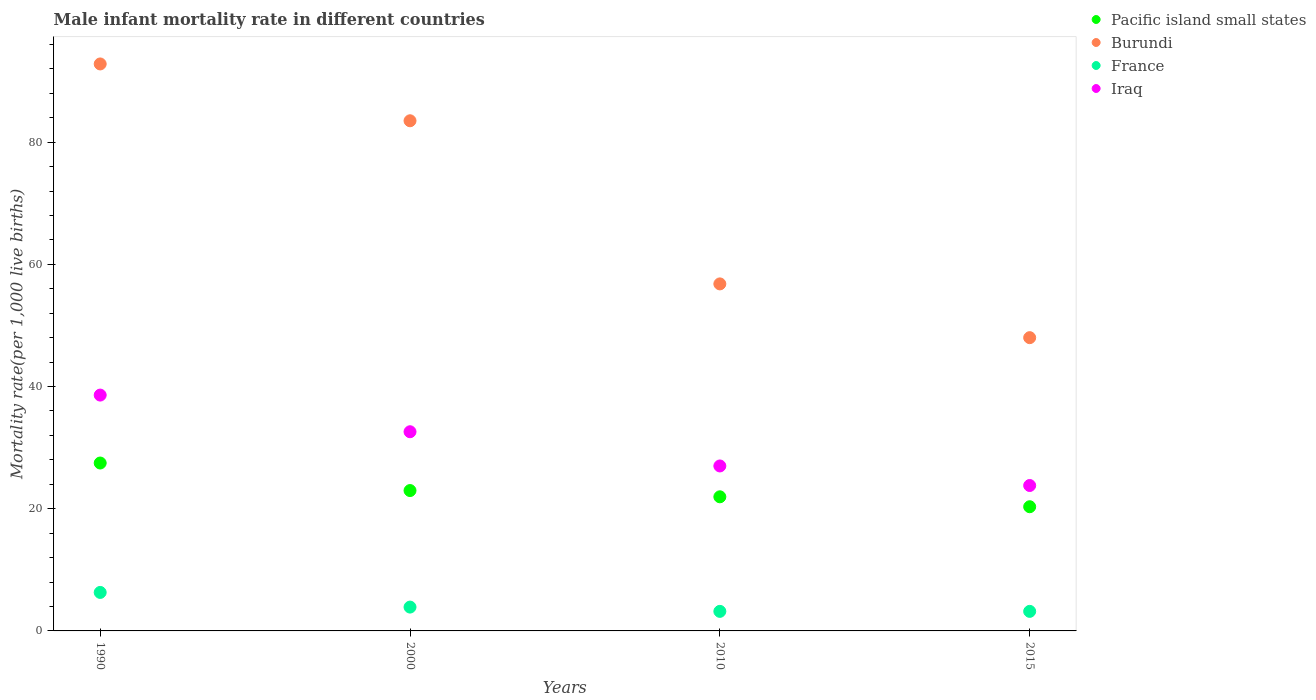How many different coloured dotlines are there?
Make the answer very short. 4. Is the number of dotlines equal to the number of legend labels?
Provide a succinct answer. Yes. What is the male infant mortality rate in Iraq in 2010?
Make the answer very short. 27. Across all years, what is the maximum male infant mortality rate in Pacific island small states?
Provide a short and direct response. 27.48. Across all years, what is the minimum male infant mortality rate in Pacific island small states?
Provide a succinct answer. 20.33. In which year was the male infant mortality rate in Iraq minimum?
Provide a short and direct response. 2015. What is the total male infant mortality rate in Iraq in the graph?
Provide a succinct answer. 122. What is the difference between the male infant mortality rate in France in 2000 and the male infant mortality rate in Burundi in 2010?
Make the answer very short. -52.9. What is the average male infant mortality rate in Pacific island small states per year?
Give a very brief answer. 23.18. In the year 2010, what is the difference between the male infant mortality rate in Pacific island small states and male infant mortality rate in Iraq?
Keep it short and to the point. -5.05. In how many years, is the male infant mortality rate in France greater than 64?
Give a very brief answer. 0. What is the ratio of the male infant mortality rate in Pacific island small states in 1990 to that in 2010?
Provide a short and direct response. 1.25. Is the male infant mortality rate in Iraq in 2000 less than that in 2010?
Make the answer very short. No. What is the difference between the highest and the lowest male infant mortality rate in France?
Keep it short and to the point. 3.1. In how many years, is the male infant mortality rate in Burundi greater than the average male infant mortality rate in Burundi taken over all years?
Keep it short and to the point. 2. Is it the case that in every year, the sum of the male infant mortality rate in Burundi and male infant mortality rate in Iraq  is greater than the sum of male infant mortality rate in France and male infant mortality rate in Pacific island small states?
Your answer should be very brief. Yes. Is it the case that in every year, the sum of the male infant mortality rate in Burundi and male infant mortality rate in Iraq  is greater than the male infant mortality rate in Pacific island small states?
Offer a terse response. Yes. Is the male infant mortality rate in Pacific island small states strictly greater than the male infant mortality rate in Iraq over the years?
Make the answer very short. No. Is the male infant mortality rate in France strictly less than the male infant mortality rate in Iraq over the years?
Your answer should be very brief. Yes. What is the difference between two consecutive major ticks on the Y-axis?
Make the answer very short. 20. Are the values on the major ticks of Y-axis written in scientific E-notation?
Provide a succinct answer. No. How many legend labels are there?
Your answer should be very brief. 4. How are the legend labels stacked?
Your response must be concise. Vertical. What is the title of the graph?
Your answer should be compact. Male infant mortality rate in different countries. What is the label or title of the Y-axis?
Ensure brevity in your answer.  Mortality rate(per 1,0 live births). What is the Mortality rate(per 1,000 live births) in Pacific island small states in 1990?
Offer a terse response. 27.48. What is the Mortality rate(per 1,000 live births) of Burundi in 1990?
Provide a short and direct response. 92.8. What is the Mortality rate(per 1,000 live births) of France in 1990?
Offer a terse response. 6.3. What is the Mortality rate(per 1,000 live births) in Iraq in 1990?
Offer a terse response. 38.6. What is the Mortality rate(per 1,000 live births) of Pacific island small states in 2000?
Your answer should be compact. 22.97. What is the Mortality rate(per 1,000 live births) of Burundi in 2000?
Provide a succinct answer. 83.5. What is the Mortality rate(per 1,000 live births) of Iraq in 2000?
Your answer should be compact. 32.6. What is the Mortality rate(per 1,000 live births) of Pacific island small states in 2010?
Offer a terse response. 21.95. What is the Mortality rate(per 1,000 live births) of Burundi in 2010?
Your response must be concise. 56.8. What is the Mortality rate(per 1,000 live births) in France in 2010?
Your answer should be very brief. 3.2. What is the Mortality rate(per 1,000 live births) of Pacific island small states in 2015?
Your response must be concise. 20.33. What is the Mortality rate(per 1,000 live births) of Iraq in 2015?
Provide a succinct answer. 23.8. Across all years, what is the maximum Mortality rate(per 1,000 live births) in Pacific island small states?
Ensure brevity in your answer.  27.48. Across all years, what is the maximum Mortality rate(per 1,000 live births) in Burundi?
Make the answer very short. 92.8. Across all years, what is the maximum Mortality rate(per 1,000 live births) in Iraq?
Ensure brevity in your answer.  38.6. Across all years, what is the minimum Mortality rate(per 1,000 live births) of Pacific island small states?
Ensure brevity in your answer.  20.33. Across all years, what is the minimum Mortality rate(per 1,000 live births) of Iraq?
Provide a succinct answer. 23.8. What is the total Mortality rate(per 1,000 live births) in Pacific island small states in the graph?
Make the answer very short. 92.73. What is the total Mortality rate(per 1,000 live births) in Burundi in the graph?
Offer a very short reply. 281.1. What is the total Mortality rate(per 1,000 live births) of Iraq in the graph?
Offer a terse response. 122. What is the difference between the Mortality rate(per 1,000 live births) of Pacific island small states in 1990 and that in 2000?
Offer a terse response. 4.51. What is the difference between the Mortality rate(per 1,000 live births) in France in 1990 and that in 2000?
Keep it short and to the point. 2.4. What is the difference between the Mortality rate(per 1,000 live births) of Pacific island small states in 1990 and that in 2010?
Offer a terse response. 5.53. What is the difference between the Mortality rate(per 1,000 live births) of France in 1990 and that in 2010?
Provide a short and direct response. 3.1. What is the difference between the Mortality rate(per 1,000 live births) in Pacific island small states in 1990 and that in 2015?
Offer a terse response. 7.16. What is the difference between the Mortality rate(per 1,000 live births) of Burundi in 1990 and that in 2015?
Ensure brevity in your answer.  44.8. What is the difference between the Mortality rate(per 1,000 live births) of France in 1990 and that in 2015?
Keep it short and to the point. 3.1. What is the difference between the Mortality rate(per 1,000 live births) in Iraq in 1990 and that in 2015?
Ensure brevity in your answer.  14.8. What is the difference between the Mortality rate(per 1,000 live births) of Pacific island small states in 2000 and that in 2010?
Ensure brevity in your answer.  1.02. What is the difference between the Mortality rate(per 1,000 live births) in Burundi in 2000 and that in 2010?
Keep it short and to the point. 26.7. What is the difference between the Mortality rate(per 1,000 live births) in Pacific island small states in 2000 and that in 2015?
Provide a short and direct response. 2.65. What is the difference between the Mortality rate(per 1,000 live births) in Burundi in 2000 and that in 2015?
Provide a short and direct response. 35.5. What is the difference between the Mortality rate(per 1,000 live births) of Pacific island small states in 2010 and that in 2015?
Offer a terse response. 1.62. What is the difference between the Mortality rate(per 1,000 live births) in Burundi in 2010 and that in 2015?
Your response must be concise. 8.8. What is the difference between the Mortality rate(per 1,000 live births) of Iraq in 2010 and that in 2015?
Make the answer very short. 3.2. What is the difference between the Mortality rate(per 1,000 live births) of Pacific island small states in 1990 and the Mortality rate(per 1,000 live births) of Burundi in 2000?
Ensure brevity in your answer.  -56.02. What is the difference between the Mortality rate(per 1,000 live births) of Pacific island small states in 1990 and the Mortality rate(per 1,000 live births) of France in 2000?
Make the answer very short. 23.58. What is the difference between the Mortality rate(per 1,000 live births) in Pacific island small states in 1990 and the Mortality rate(per 1,000 live births) in Iraq in 2000?
Your answer should be very brief. -5.12. What is the difference between the Mortality rate(per 1,000 live births) in Burundi in 1990 and the Mortality rate(per 1,000 live births) in France in 2000?
Provide a short and direct response. 88.9. What is the difference between the Mortality rate(per 1,000 live births) of Burundi in 1990 and the Mortality rate(per 1,000 live births) of Iraq in 2000?
Give a very brief answer. 60.2. What is the difference between the Mortality rate(per 1,000 live births) of France in 1990 and the Mortality rate(per 1,000 live births) of Iraq in 2000?
Ensure brevity in your answer.  -26.3. What is the difference between the Mortality rate(per 1,000 live births) of Pacific island small states in 1990 and the Mortality rate(per 1,000 live births) of Burundi in 2010?
Your answer should be compact. -29.32. What is the difference between the Mortality rate(per 1,000 live births) in Pacific island small states in 1990 and the Mortality rate(per 1,000 live births) in France in 2010?
Ensure brevity in your answer.  24.28. What is the difference between the Mortality rate(per 1,000 live births) of Pacific island small states in 1990 and the Mortality rate(per 1,000 live births) of Iraq in 2010?
Your answer should be compact. 0.48. What is the difference between the Mortality rate(per 1,000 live births) of Burundi in 1990 and the Mortality rate(per 1,000 live births) of France in 2010?
Keep it short and to the point. 89.6. What is the difference between the Mortality rate(per 1,000 live births) of Burundi in 1990 and the Mortality rate(per 1,000 live births) of Iraq in 2010?
Provide a short and direct response. 65.8. What is the difference between the Mortality rate(per 1,000 live births) of France in 1990 and the Mortality rate(per 1,000 live births) of Iraq in 2010?
Ensure brevity in your answer.  -20.7. What is the difference between the Mortality rate(per 1,000 live births) in Pacific island small states in 1990 and the Mortality rate(per 1,000 live births) in Burundi in 2015?
Your answer should be very brief. -20.52. What is the difference between the Mortality rate(per 1,000 live births) in Pacific island small states in 1990 and the Mortality rate(per 1,000 live births) in France in 2015?
Provide a succinct answer. 24.28. What is the difference between the Mortality rate(per 1,000 live births) of Pacific island small states in 1990 and the Mortality rate(per 1,000 live births) of Iraq in 2015?
Your response must be concise. 3.68. What is the difference between the Mortality rate(per 1,000 live births) in Burundi in 1990 and the Mortality rate(per 1,000 live births) in France in 2015?
Offer a very short reply. 89.6. What is the difference between the Mortality rate(per 1,000 live births) in France in 1990 and the Mortality rate(per 1,000 live births) in Iraq in 2015?
Offer a terse response. -17.5. What is the difference between the Mortality rate(per 1,000 live births) of Pacific island small states in 2000 and the Mortality rate(per 1,000 live births) of Burundi in 2010?
Make the answer very short. -33.83. What is the difference between the Mortality rate(per 1,000 live births) in Pacific island small states in 2000 and the Mortality rate(per 1,000 live births) in France in 2010?
Make the answer very short. 19.77. What is the difference between the Mortality rate(per 1,000 live births) in Pacific island small states in 2000 and the Mortality rate(per 1,000 live births) in Iraq in 2010?
Make the answer very short. -4.03. What is the difference between the Mortality rate(per 1,000 live births) of Burundi in 2000 and the Mortality rate(per 1,000 live births) of France in 2010?
Ensure brevity in your answer.  80.3. What is the difference between the Mortality rate(per 1,000 live births) of Burundi in 2000 and the Mortality rate(per 1,000 live births) of Iraq in 2010?
Your response must be concise. 56.5. What is the difference between the Mortality rate(per 1,000 live births) of France in 2000 and the Mortality rate(per 1,000 live births) of Iraq in 2010?
Your answer should be very brief. -23.1. What is the difference between the Mortality rate(per 1,000 live births) in Pacific island small states in 2000 and the Mortality rate(per 1,000 live births) in Burundi in 2015?
Your answer should be very brief. -25.03. What is the difference between the Mortality rate(per 1,000 live births) in Pacific island small states in 2000 and the Mortality rate(per 1,000 live births) in France in 2015?
Give a very brief answer. 19.77. What is the difference between the Mortality rate(per 1,000 live births) in Pacific island small states in 2000 and the Mortality rate(per 1,000 live births) in Iraq in 2015?
Provide a short and direct response. -0.83. What is the difference between the Mortality rate(per 1,000 live births) in Burundi in 2000 and the Mortality rate(per 1,000 live births) in France in 2015?
Provide a short and direct response. 80.3. What is the difference between the Mortality rate(per 1,000 live births) of Burundi in 2000 and the Mortality rate(per 1,000 live births) of Iraq in 2015?
Keep it short and to the point. 59.7. What is the difference between the Mortality rate(per 1,000 live births) of France in 2000 and the Mortality rate(per 1,000 live births) of Iraq in 2015?
Give a very brief answer. -19.9. What is the difference between the Mortality rate(per 1,000 live births) in Pacific island small states in 2010 and the Mortality rate(per 1,000 live births) in Burundi in 2015?
Offer a terse response. -26.05. What is the difference between the Mortality rate(per 1,000 live births) in Pacific island small states in 2010 and the Mortality rate(per 1,000 live births) in France in 2015?
Provide a succinct answer. 18.75. What is the difference between the Mortality rate(per 1,000 live births) of Pacific island small states in 2010 and the Mortality rate(per 1,000 live births) of Iraq in 2015?
Provide a succinct answer. -1.85. What is the difference between the Mortality rate(per 1,000 live births) of Burundi in 2010 and the Mortality rate(per 1,000 live births) of France in 2015?
Your answer should be compact. 53.6. What is the difference between the Mortality rate(per 1,000 live births) of France in 2010 and the Mortality rate(per 1,000 live births) of Iraq in 2015?
Make the answer very short. -20.6. What is the average Mortality rate(per 1,000 live births) in Pacific island small states per year?
Offer a terse response. 23.18. What is the average Mortality rate(per 1,000 live births) of Burundi per year?
Offer a terse response. 70.28. What is the average Mortality rate(per 1,000 live births) in France per year?
Offer a terse response. 4.15. What is the average Mortality rate(per 1,000 live births) of Iraq per year?
Provide a short and direct response. 30.5. In the year 1990, what is the difference between the Mortality rate(per 1,000 live births) in Pacific island small states and Mortality rate(per 1,000 live births) in Burundi?
Provide a short and direct response. -65.32. In the year 1990, what is the difference between the Mortality rate(per 1,000 live births) of Pacific island small states and Mortality rate(per 1,000 live births) of France?
Make the answer very short. 21.18. In the year 1990, what is the difference between the Mortality rate(per 1,000 live births) of Pacific island small states and Mortality rate(per 1,000 live births) of Iraq?
Your response must be concise. -11.12. In the year 1990, what is the difference between the Mortality rate(per 1,000 live births) of Burundi and Mortality rate(per 1,000 live births) of France?
Your answer should be very brief. 86.5. In the year 1990, what is the difference between the Mortality rate(per 1,000 live births) of Burundi and Mortality rate(per 1,000 live births) of Iraq?
Ensure brevity in your answer.  54.2. In the year 1990, what is the difference between the Mortality rate(per 1,000 live births) in France and Mortality rate(per 1,000 live births) in Iraq?
Your answer should be compact. -32.3. In the year 2000, what is the difference between the Mortality rate(per 1,000 live births) of Pacific island small states and Mortality rate(per 1,000 live births) of Burundi?
Ensure brevity in your answer.  -60.53. In the year 2000, what is the difference between the Mortality rate(per 1,000 live births) in Pacific island small states and Mortality rate(per 1,000 live births) in France?
Give a very brief answer. 19.07. In the year 2000, what is the difference between the Mortality rate(per 1,000 live births) of Pacific island small states and Mortality rate(per 1,000 live births) of Iraq?
Make the answer very short. -9.63. In the year 2000, what is the difference between the Mortality rate(per 1,000 live births) in Burundi and Mortality rate(per 1,000 live births) in France?
Provide a succinct answer. 79.6. In the year 2000, what is the difference between the Mortality rate(per 1,000 live births) of Burundi and Mortality rate(per 1,000 live births) of Iraq?
Provide a short and direct response. 50.9. In the year 2000, what is the difference between the Mortality rate(per 1,000 live births) in France and Mortality rate(per 1,000 live births) in Iraq?
Your answer should be compact. -28.7. In the year 2010, what is the difference between the Mortality rate(per 1,000 live births) of Pacific island small states and Mortality rate(per 1,000 live births) of Burundi?
Make the answer very short. -34.85. In the year 2010, what is the difference between the Mortality rate(per 1,000 live births) of Pacific island small states and Mortality rate(per 1,000 live births) of France?
Provide a succinct answer. 18.75. In the year 2010, what is the difference between the Mortality rate(per 1,000 live births) of Pacific island small states and Mortality rate(per 1,000 live births) of Iraq?
Provide a succinct answer. -5.05. In the year 2010, what is the difference between the Mortality rate(per 1,000 live births) of Burundi and Mortality rate(per 1,000 live births) of France?
Your answer should be compact. 53.6. In the year 2010, what is the difference between the Mortality rate(per 1,000 live births) of Burundi and Mortality rate(per 1,000 live births) of Iraq?
Make the answer very short. 29.8. In the year 2010, what is the difference between the Mortality rate(per 1,000 live births) in France and Mortality rate(per 1,000 live births) in Iraq?
Provide a short and direct response. -23.8. In the year 2015, what is the difference between the Mortality rate(per 1,000 live births) in Pacific island small states and Mortality rate(per 1,000 live births) in Burundi?
Make the answer very short. -27.67. In the year 2015, what is the difference between the Mortality rate(per 1,000 live births) of Pacific island small states and Mortality rate(per 1,000 live births) of France?
Your answer should be very brief. 17.13. In the year 2015, what is the difference between the Mortality rate(per 1,000 live births) in Pacific island small states and Mortality rate(per 1,000 live births) in Iraq?
Provide a short and direct response. -3.47. In the year 2015, what is the difference between the Mortality rate(per 1,000 live births) in Burundi and Mortality rate(per 1,000 live births) in France?
Provide a succinct answer. 44.8. In the year 2015, what is the difference between the Mortality rate(per 1,000 live births) in Burundi and Mortality rate(per 1,000 live births) in Iraq?
Offer a very short reply. 24.2. In the year 2015, what is the difference between the Mortality rate(per 1,000 live births) in France and Mortality rate(per 1,000 live births) in Iraq?
Your answer should be very brief. -20.6. What is the ratio of the Mortality rate(per 1,000 live births) of Pacific island small states in 1990 to that in 2000?
Provide a succinct answer. 1.2. What is the ratio of the Mortality rate(per 1,000 live births) in Burundi in 1990 to that in 2000?
Your answer should be very brief. 1.11. What is the ratio of the Mortality rate(per 1,000 live births) of France in 1990 to that in 2000?
Give a very brief answer. 1.62. What is the ratio of the Mortality rate(per 1,000 live births) of Iraq in 1990 to that in 2000?
Offer a terse response. 1.18. What is the ratio of the Mortality rate(per 1,000 live births) in Pacific island small states in 1990 to that in 2010?
Keep it short and to the point. 1.25. What is the ratio of the Mortality rate(per 1,000 live births) of Burundi in 1990 to that in 2010?
Offer a very short reply. 1.63. What is the ratio of the Mortality rate(per 1,000 live births) of France in 1990 to that in 2010?
Offer a terse response. 1.97. What is the ratio of the Mortality rate(per 1,000 live births) in Iraq in 1990 to that in 2010?
Provide a short and direct response. 1.43. What is the ratio of the Mortality rate(per 1,000 live births) in Pacific island small states in 1990 to that in 2015?
Your answer should be compact. 1.35. What is the ratio of the Mortality rate(per 1,000 live births) in Burundi in 1990 to that in 2015?
Offer a very short reply. 1.93. What is the ratio of the Mortality rate(per 1,000 live births) in France in 1990 to that in 2015?
Give a very brief answer. 1.97. What is the ratio of the Mortality rate(per 1,000 live births) in Iraq in 1990 to that in 2015?
Make the answer very short. 1.62. What is the ratio of the Mortality rate(per 1,000 live births) in Pacific island small states in 2000 to that in 2010?
Your response must be concise. 1.05. What is the ratio of the Mortality rate(per 1,000 live births) of Burundi in 2000 to that in 2010?
Keep it short and to the point. 1.47. What is the ratio of the Mortality rate(per 1,000 live births) in France in 2000 to that in 2010?
Your answer should be compact. 1.22. What is the ratio of the Mortality rate(per 1,000 live births) in Iraq in 2000 to that in 2010?
Offer a very short reply. 1.21. What is the ratio of the Mortality rate(per 1,000 live births) in Pacific island small states in 2000 to that in 2015?
Offer a terse response. 1.13. What is the ratio of the Mortality rate(per 1,000 live births) of Burundi in 2000 to that in 2015?
Offer a very short reply. 1.74. What is the ratio of the Mortality rate(per 1,000 live births) of France in 2000 to that in 2015?
Give a very brief answer. 1.22. What is the ratio of the Mortality rate(per 1,000 live births) in Iraq in 2000 to that in 2015?
Your answer should be compact. 1.37. What is the ratio of the Mortality rate(per 1,000 live births) of Pacific island small states in 2010 to that in 2015?
Your response must be concise. 1.08. What is the ratio of the Mortality rate(per 1,000 live births) in Burundi in 2010 to that in 2015?
Give a very brief answer. 1.18. What is the ratio of the Mortality rate(per 1,000 live births) in Iraq in 2010 to that in 2015?
Give a very brief answer. 1.13. What is the difference between the highest and the second highest Mortality rate(per 1,000 live births) in Pacific island small states?
Provide a short and direct response. 4.51. What is the difference between the highest and the second highest Mortality rate(per 1,000 live births) of Burundi?
Offer a terse response. 9.3. What is the difference between the highest and the second highest Mortality rate(per 1,000 live births) in Iraq?
Offer a very short reply. 6. What is the difference between the highest and the lowest Mortality rate(per 1,000 live births) of Pacific island small states?
Provide a short and direct response. 7.16. What is the difference between the highest and the lowest Mortality rate(per 1,000 live births) in Burundi?
Provide a short and direct response. 44.8. 